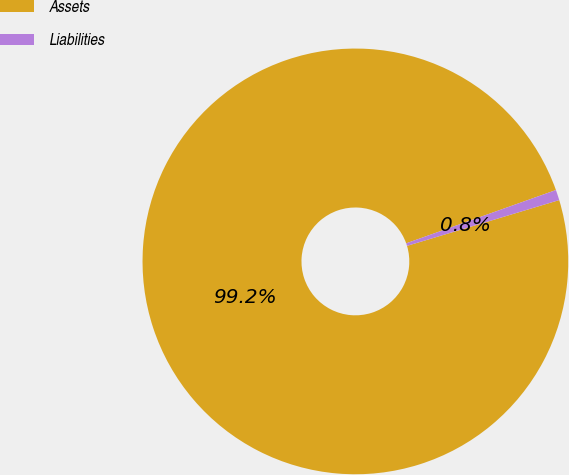Convert chart to OTSL. <chart><loc_0><loc_0><loc_500><loc_500><pie_chart><fcel>Assets<fcel>Liabilities<nl><fcel>99.21%<fcel>0.79%<nl></chart> 